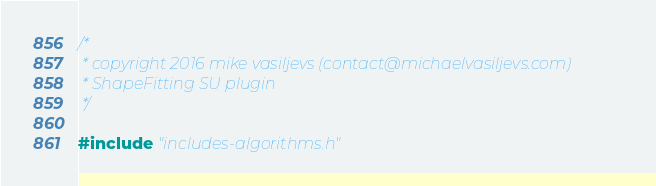Convert code to text. <code><loc_0><loc_0><loc_500><loc_500><_C++_>/*
 * copyright 2016 mike vasiljevs (contact@michaelvasiljevs.com)
 * ShapeFitting SU plugin
 */
 
#include "includes-algorithms.h"


</code> 